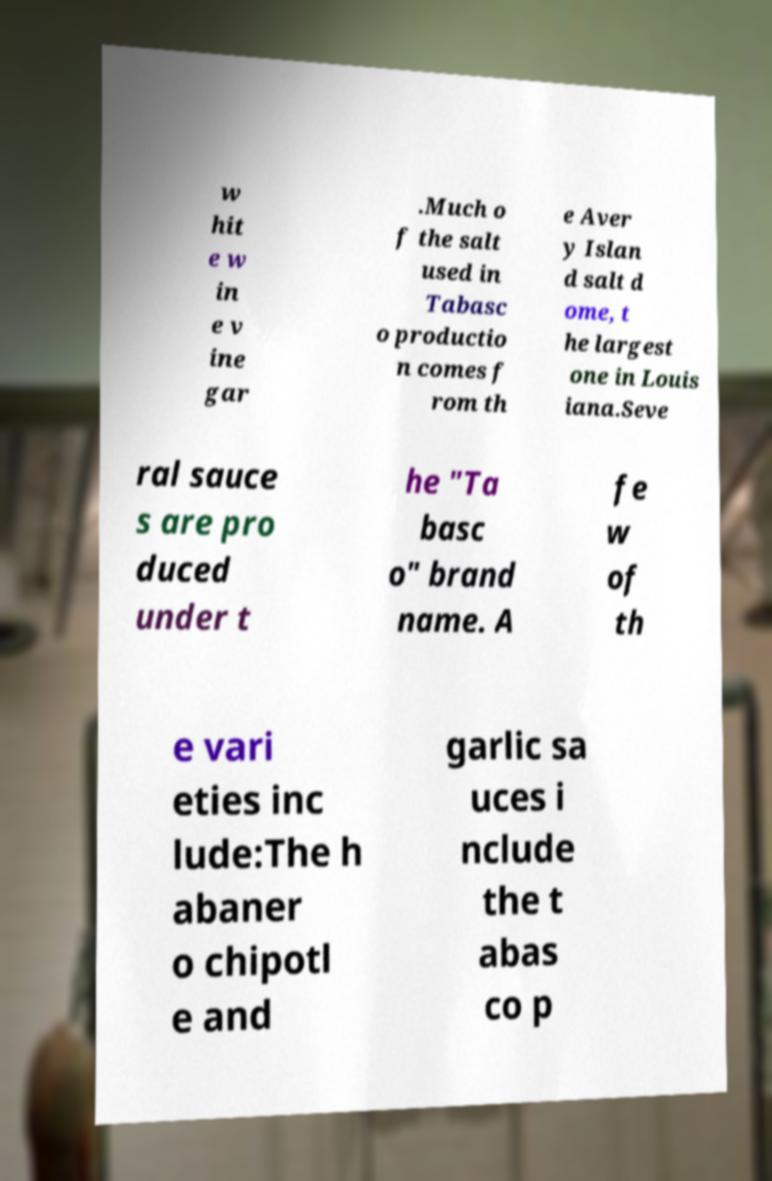I need the written content from this picture converted into text. Can you do that? w hit e w in e v ine gar .Much o f the salt used in Tabasc o productio n comes f rom th e Aver y Islan d salt d ome, t he largest one in Louis iana.Seve ral sauce s are pro duced under t he "Ta basc o" brand name. A fe w of th e vari eties inc lude:The h abaner o chipotl e and garlic sa uces i nclude the t abas co p 